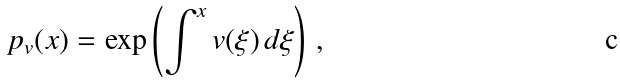Convert formula to latex. <formula><loc_0><loc_0><loc_500><loc_500>\ p _ { v } ( x ) = \exp \left ( \int ^ { x } v ( \xi ) \, d \xi \right ) \, ,</formula> 